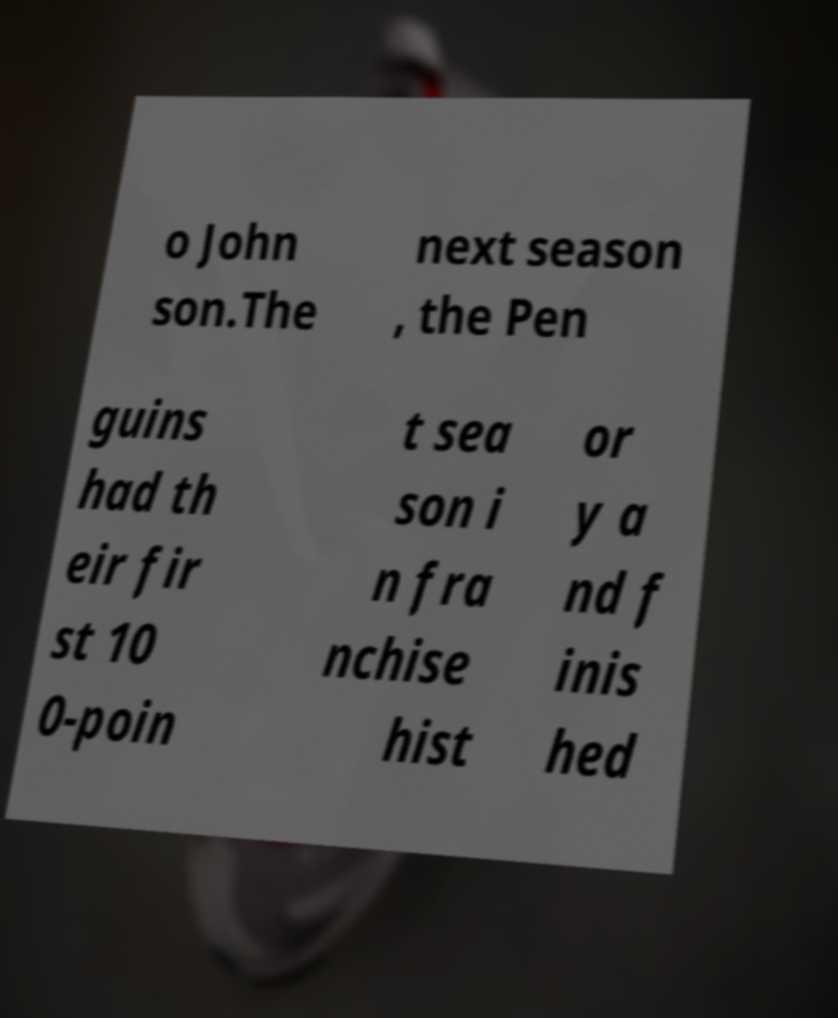Could you assist in decoding the text presented in this image and type it out clearly? o John son.The next season , the Pen guins had th eir fir st 10 0-poin t sea son i n fra nchise hist or y a nd f inis hed 